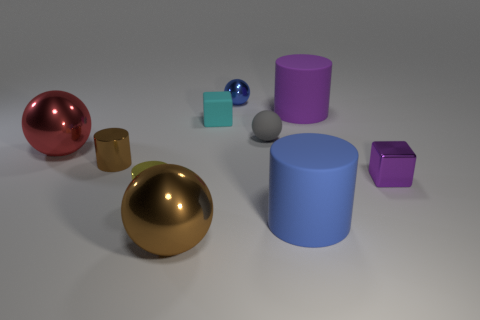There is a sphere that is behind the large cylinder that is behind the large red metallic ball; what color is it?
Your answer should be very brief. Blue. How big is the brown object that is on the left side of the big ball that is in front of the small shiny object that is to the right of the big blue cylinder?
Your answer should be compact. Small. Are the tiny blue thing and the tiny block right of the blue cylinder made of the same material?
Provide a succinct answer. Yes. What size is the yellow object that is the same material as the small purple block?
Your answer should be compact. Small. Is there a big gray thing of the same shape as the small purple object?
Make the answer very short. No. What number of things are big matte cylinders that are to the right of the red object or big yellow shiny cubes?
Your response must be concise. 2. There is a cylinder that is the same color as the small shiny sphere; what size is it?
Provide a succinct answer. Large. Do the ball that is in front of the big blue cylinder and the ball on the left side of the large brown shiny object have the same color?
Provide a short and direct response. No. How big is the metal cube?
Offer a terse response. Small. What number of small things are either metallic blocks or brown shiny spheres?
Your answer should be very brief. 1. 